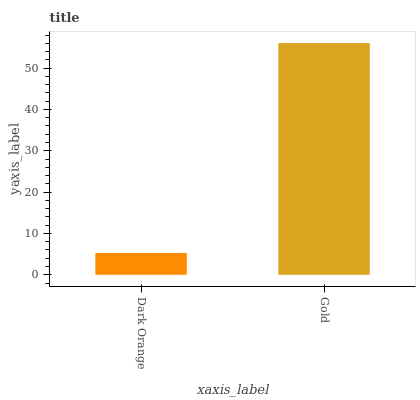Is Dark Orange the minimum?
Answer yes or no. Yes. Is Gold the maximum?
Answer yes or no. Yes. Is Gold the minimum?
Answer yes or no. No. Is Gold greater than Dark Orange?
Answer yes or no. Yes. Is Dark Orange less than Gold?
Answer yes or no. Yes. Is Dark Orange greater than Gold?
Answer yes or no. No. Is Gold less than Dark Orange?
Answer yes or no. No. Is Gold the high median?
Answer yes or no. Yes. Is Dark Orange the low median?
Answer yes or no. Yes. Is Dark Orange the high median?
Answer yes or no. No. Is Gold the low median?
Answer yes or no. No. 